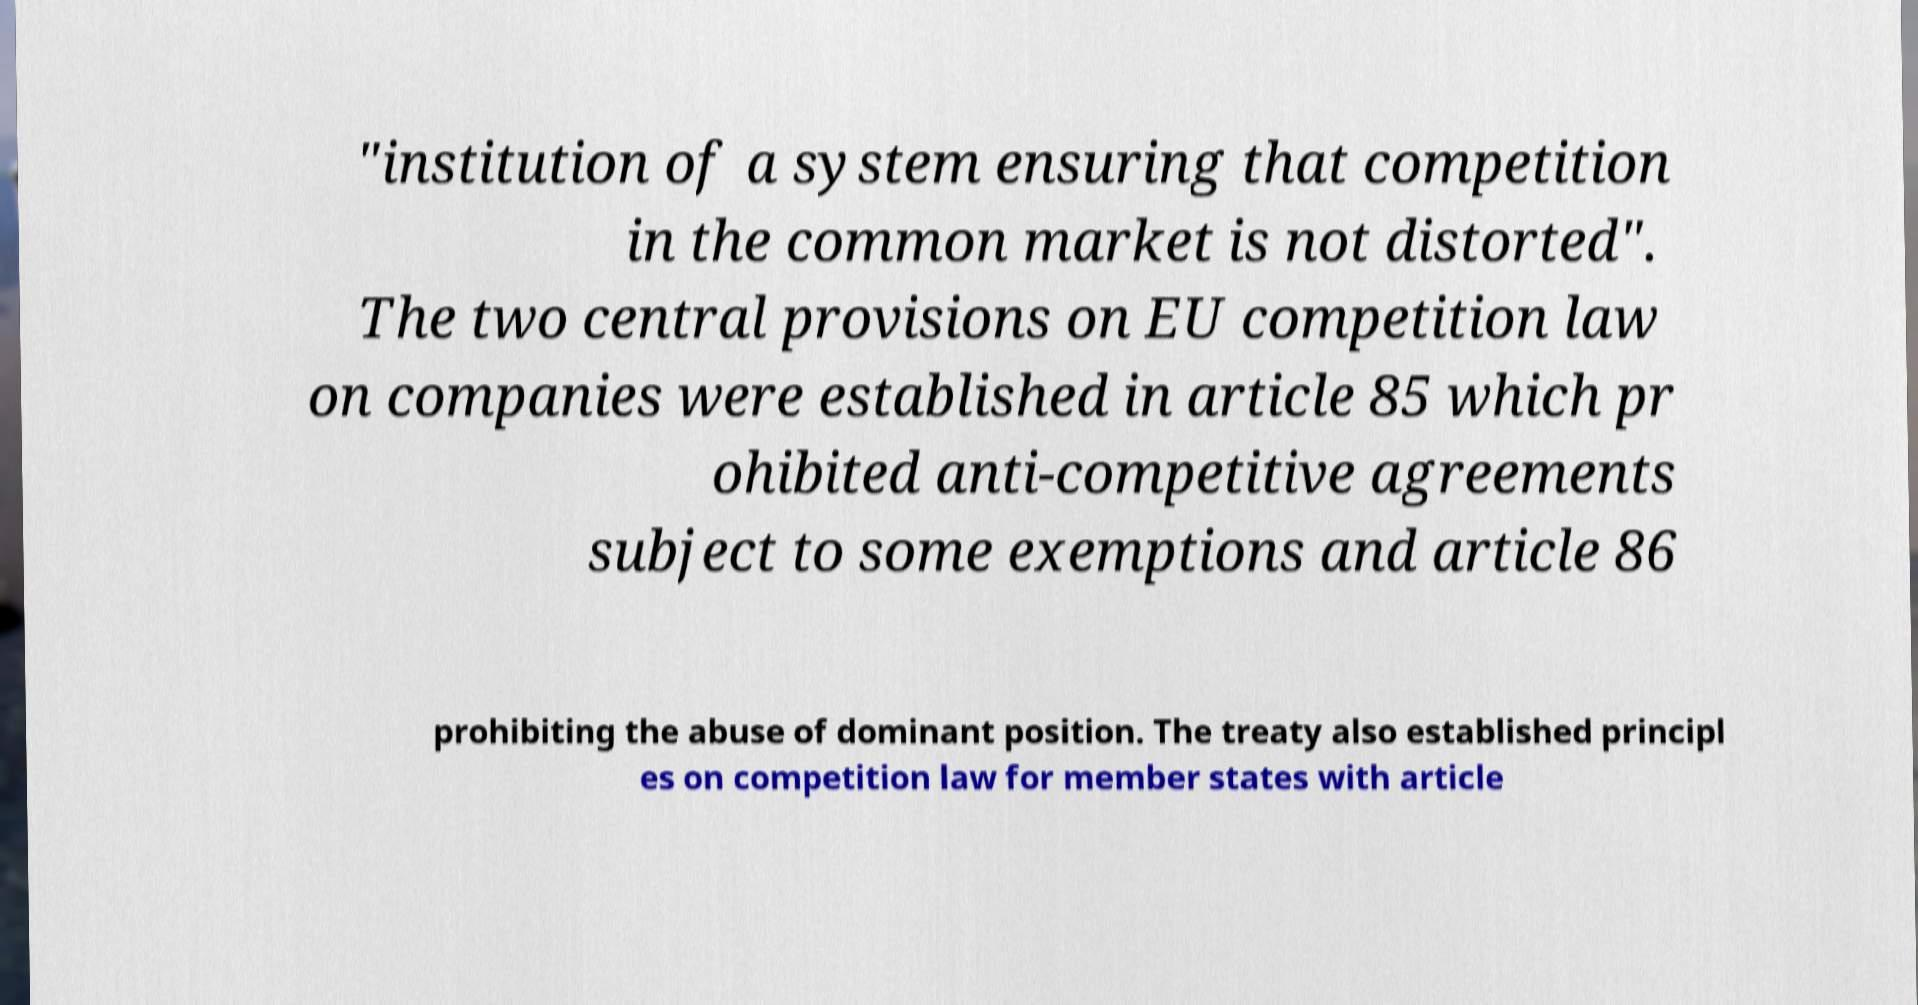Please read and relay the text visible in this image. What does it say? "institution of a system ensuring that competition in the common market is not distorted". The two central provisions on EU competition law on companies were established in article 85 which pr ohibited anti-competitive agreements subject to some exemptions and article 86 prohibiting the abuse of dominant position. The treaty also established principl es on competition law for member states with article 